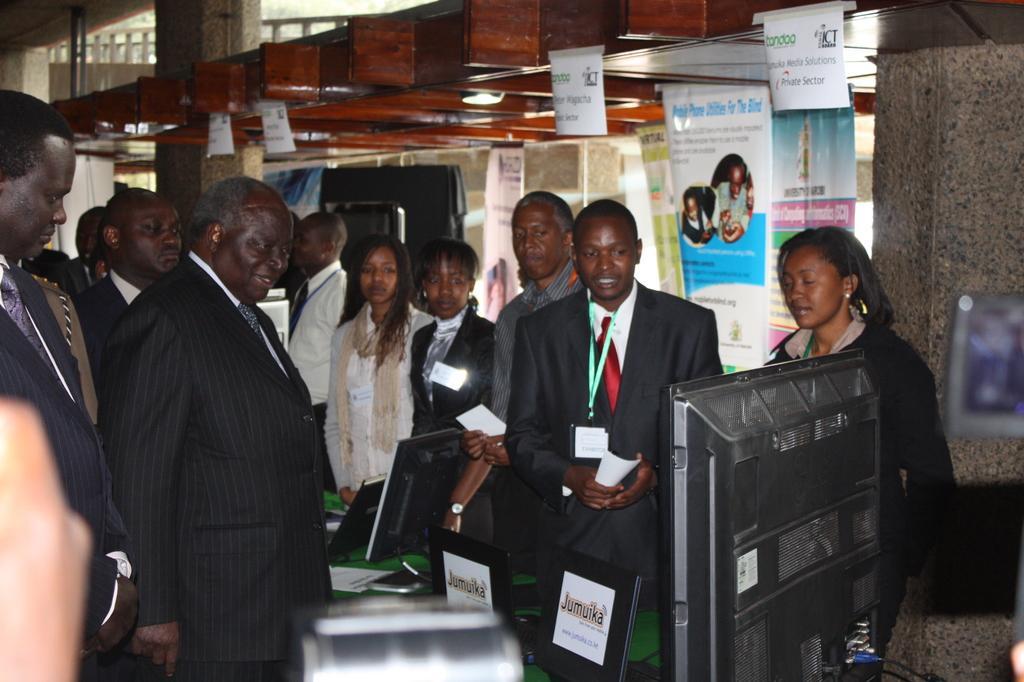Describe this image in one or two sentences. In this picture we can see some people are standing and some of them are wearing the suits and some of them are holding papers. At the bottom of the image we can see a screen, bottle and table. On the table we can see the screens, papers. In the background of the image we can see the pillars, posters, railing. 